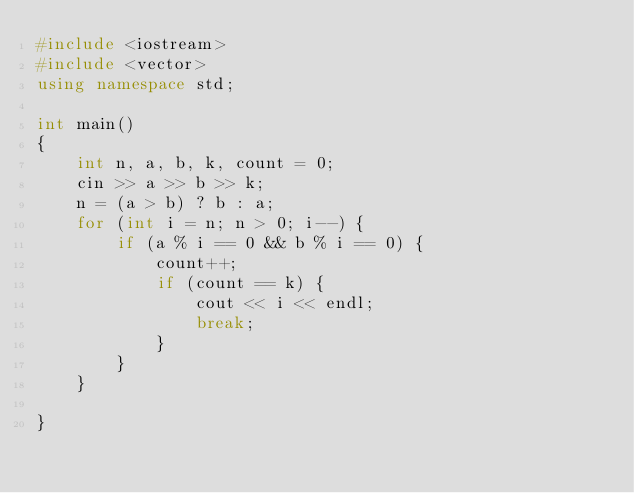Convert code to text. <code><loc_0><loc_0><loc_500><loc_500><_C++_>#include <iostream>
#include <vector>
using namespace std;

int main()
{
    int n, a, b, k, count = 0;
    cin >> a >> b >> k;
    n = (a > b) ? b : a;
    for (int i = n; n > 0; i--) {
        if (a % i == 0 && b % i == 0) {
            count++;
            if (count == k) {
                cout << i << endl;
                break;
            }
        }
    }

}</code> 